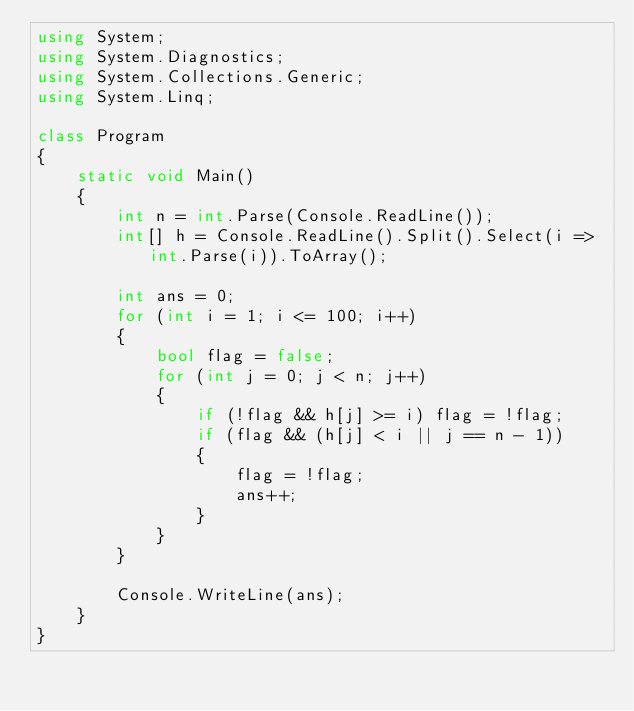Convert code to text. <code><loc_0><loc_0><loc_500><loc_500><_C#_>using System;
using System.Diagnostics;
using System.Collections.Generic;
using System.Linq;

class Program
{
    static void Main()
    {
        int n = int.Parse(Console.ReadLine());
        int[] h = Console.ReadLine().Split().Select(i => int.Parse(i)).ToArray();

        int ans = 0;
        for (int i = 1; i <= 100; i++)
        {
            bool flag = false;
            for (int j = 0; j < n; j++)
            {
                if (!flag && h[j] >= i) flag = !flag;
                if (flag && (h[j] < i || j == n - 1))
                {
                    flag = !flag;
                    ans++;
                }
            }
        }

        Console.WriteLine(ans);
    }
}</code> 